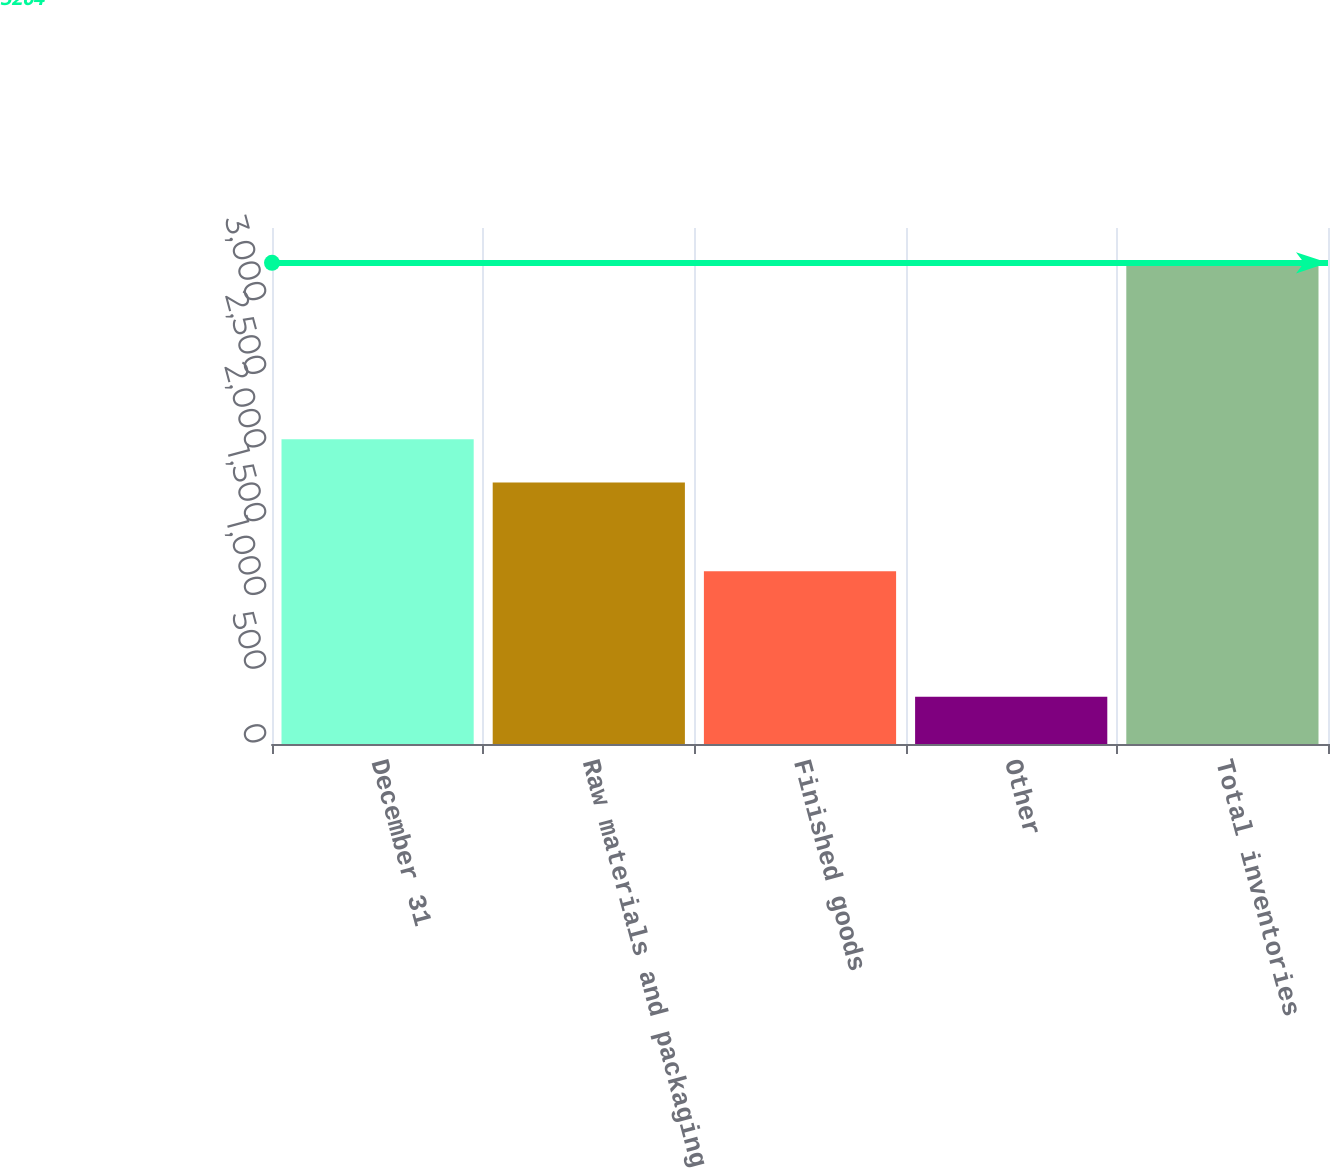<chart> <loc_0><loc_0><loc_500><loc_500><bar_chart><fcel>December 31<fcel>Raw materials and packaging<fcel>Finished goods<fcel>Other<fcel>Total inventories<nl><fcel>2067.4<fcel>1773<fcel>1171<fcel>320<fcel>3264<nl></chart> 